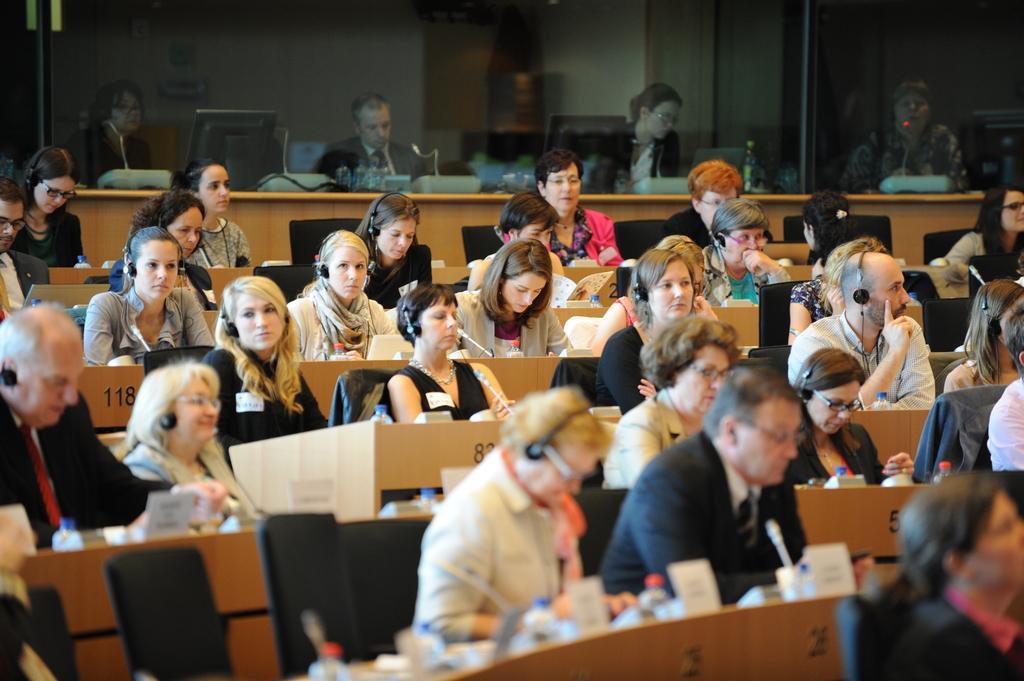How would you summarize this image in a sentence or two? In this image we can see these persons are sitting on the chairs near the desks, here we can see water bottles and mic are kept. In the background, we can see the glass door through which we can see a few more people sitting on the chair where we can see monitors and mics are kept on the table. 